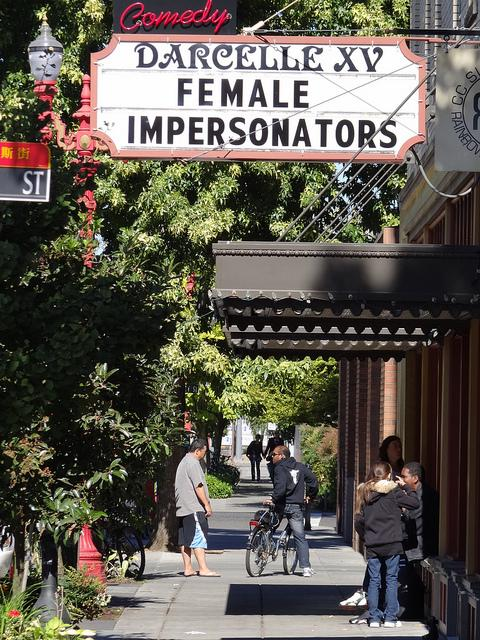Why do they impersonate females?

Choices:
A) avoid police
B) confused
C) disguise
D) money money 